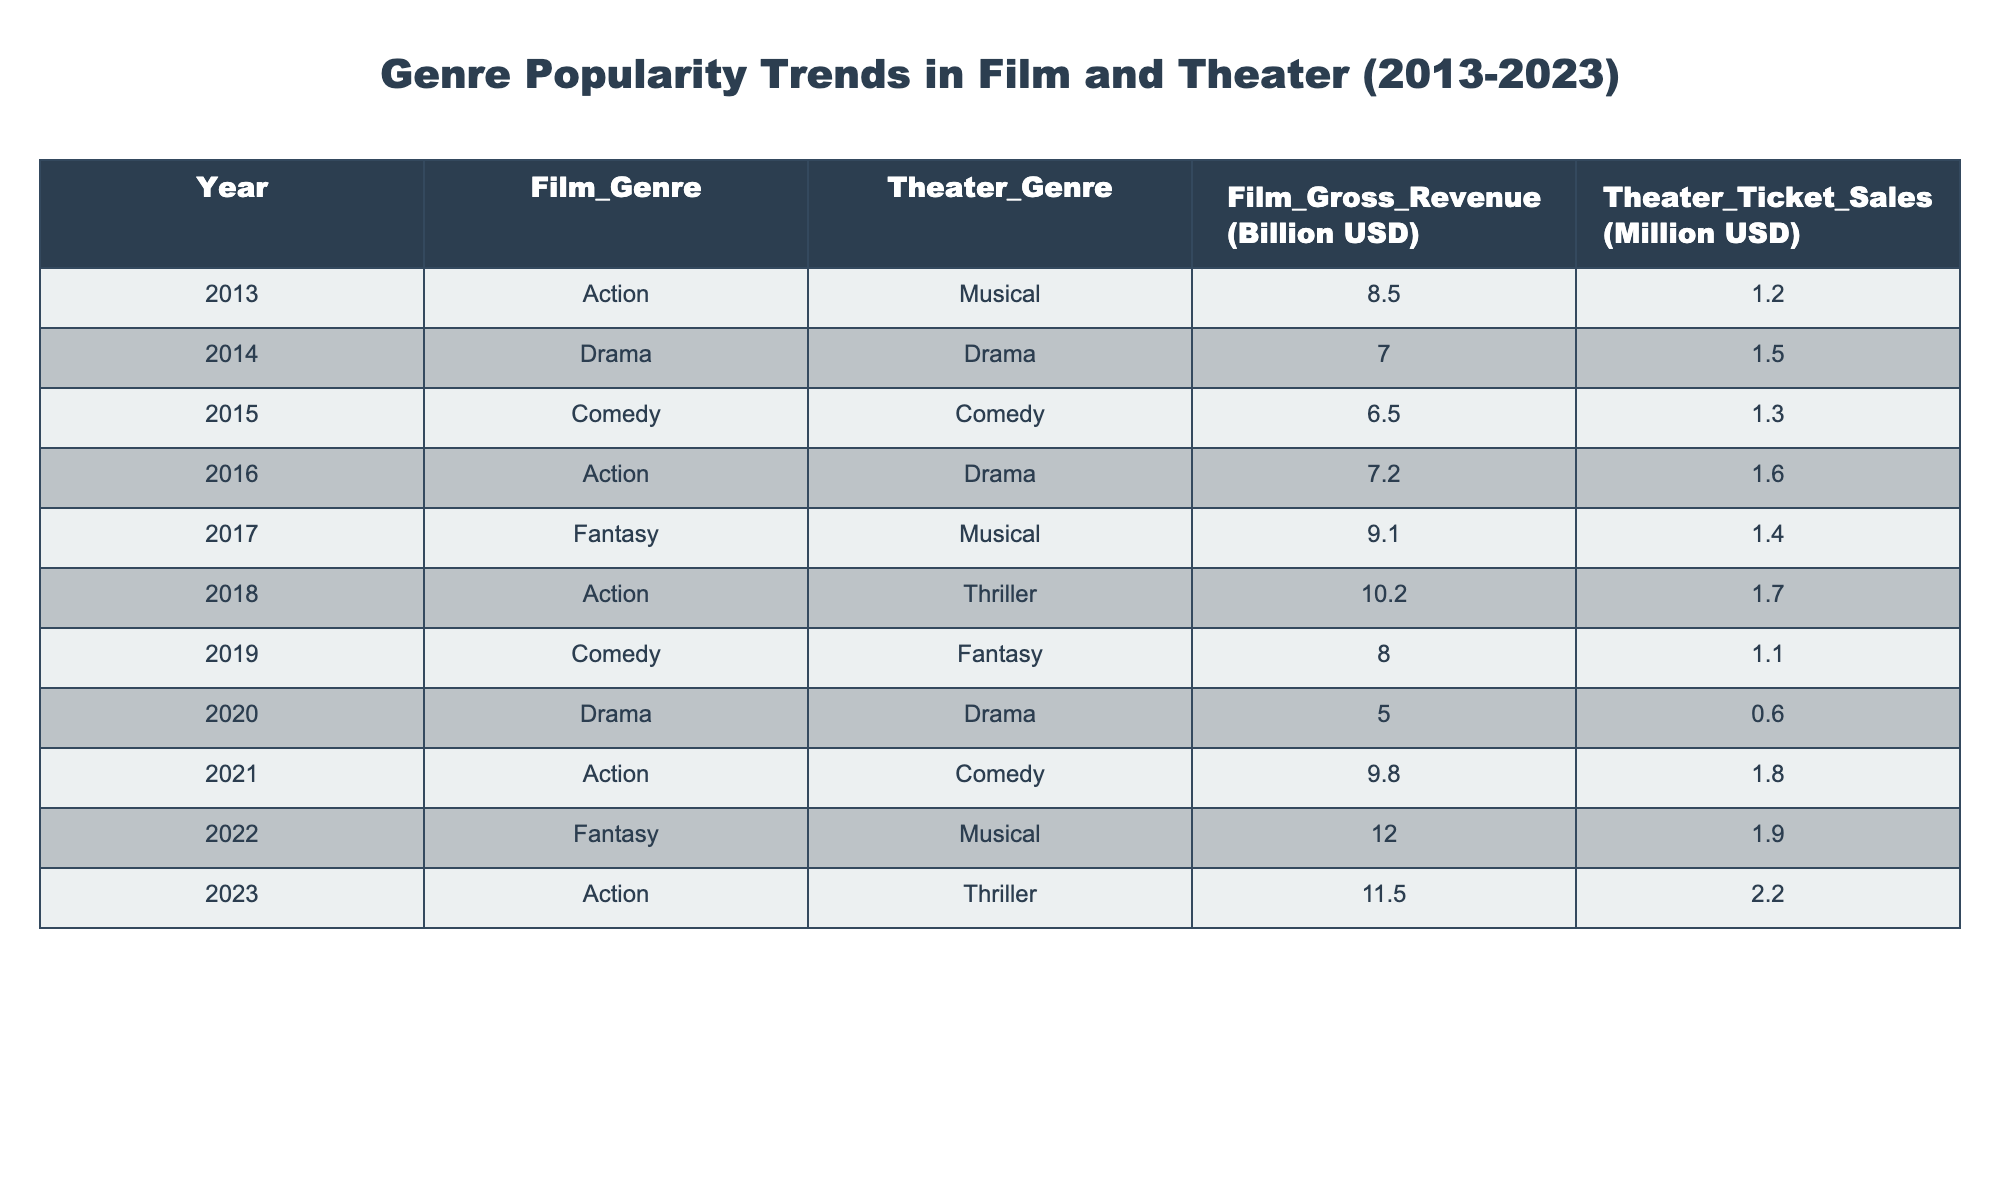What was the highest film gross revenue in the table? The highest film gross revenue is found in the data for the year 2022, which shows a revenue of 12.0 billion USD for the Fantasy genre.
Answer: 12.0 billion USD What year had the lowest theater ticket sales? The year with the lowest theater ticket sales is 2020, where sales were recorded at 0.6 million USD.
Answer: 0.6 million USD Which film genre had the highest gross revenue in 2019? In 2019, the film genre Comedy had a gross revenue of 8.0 billion USD, which is the highest for that year.
Answer: Comedy What is the average theater ticket sales from 2013 to 2023? The theater ticket sales over the years are 1.2, 1.5, 1.3, 1.6, 1.4, 1.7, 1.1, 0.6, 1.8, 1.9. Summing these gives 15.1 million USD, and averaging that over 10 years gives 15.1/10 = 1.51 million USD.
Answer: 1.51 million USD Which film genre consistently had the highest gross revenue from 2018 to 2023? From 2018 to 2023, the Action genre consistently had the highest gross revenue with amounts of 10.2 billion USD (2018), 9.8 billion USD (2021), 11.5 billion USD (2023), exceeding other genres.
Answer: Action Was there a decline in film gross revenue in 2020 compared to 2019? Yes, the film gross revenue in 2020 was 5.0 billion USD, which is a decrease from 8.0 billion USD in 2019.
Answer: Yes What was the difference in theater ticket sales between 2022 and 2023? Theater ticket sales in 2022 were 1.9 million USD and in 2023 were 2.2 million USD. The difference is 2.2 - 1.9 = 0.3 million USD.
Answer: 0.3 million USD Which theater genre had the highest sales in 2022? The highest theater ticket sales in 2022 were for the Musical genre, with 1.9 million USD.
Answer: Musical How many genres had film gross revenue exceeding 10 billion USD? The years with film gross revenues exceeding 10 billion USD are 2018 (10.2), 2021 (9.8), 2022 (12.0), and 2023 (11.5), corresponding to a total of 4 occurrences across different genres.
Answer: 4 Which year showed a significant increase in the Action film genre's revenue compared to the previous year? In 2021, the Action film genre's revenue was 9.8 billion USD, compared to 5.0 billion USD in 2020, making it a significant increase.
Answer: 2021 What is the trend in film gross revenue from 2013 to 2023? The trend in film gross revenue shows an overall increase from 8.5 billion USD in 2013 to 11.5 billion USD in 2023, indicating a growth trajectory for the film industry.
Answer: Increasing 